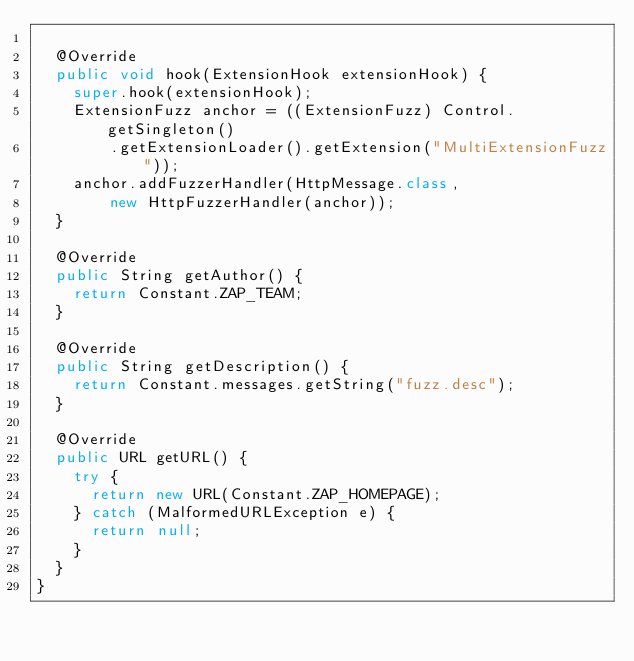Convert code to text. <code><loc_0><loc_0><loc_500><loc_500><_Java_>
	@Override
	public void hook(ExtensionHook extensionHook) {
		super.hook(extensionHook);
		ExtensionFuzz anchor = ((ExtensionFuzz) Control.getSingleton()
				.getExtensionLoader().getExtension("MultiExtensionFuzz"));
		anchor.addFuzzerHandler(HttpMessage.class,
				new HttpFuzzerHandler(anchor));
	}

	@Override
	public String getAuthor() {
		return Constant.ZAP_TEAM;
	}

	@Override
	public String getDescription() {
		return Constant.messages.getString("fuzz.desc");
	}

	@Override
	public URL getURL() {
		try {
			return new URL(Constant.ZAP_HOMEPAGE);
		} catch (MalformedURLException e) {
			return null;
		}
	}
}
</code> 